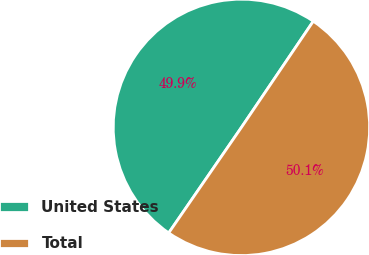Convert chart. <chart><loc_0><loc_0><loc_500><loc_500><pie_chart><fcel>United States<fcel>Total<nl><fcel>49.87%<fcel>50.13%<nl></chart> 